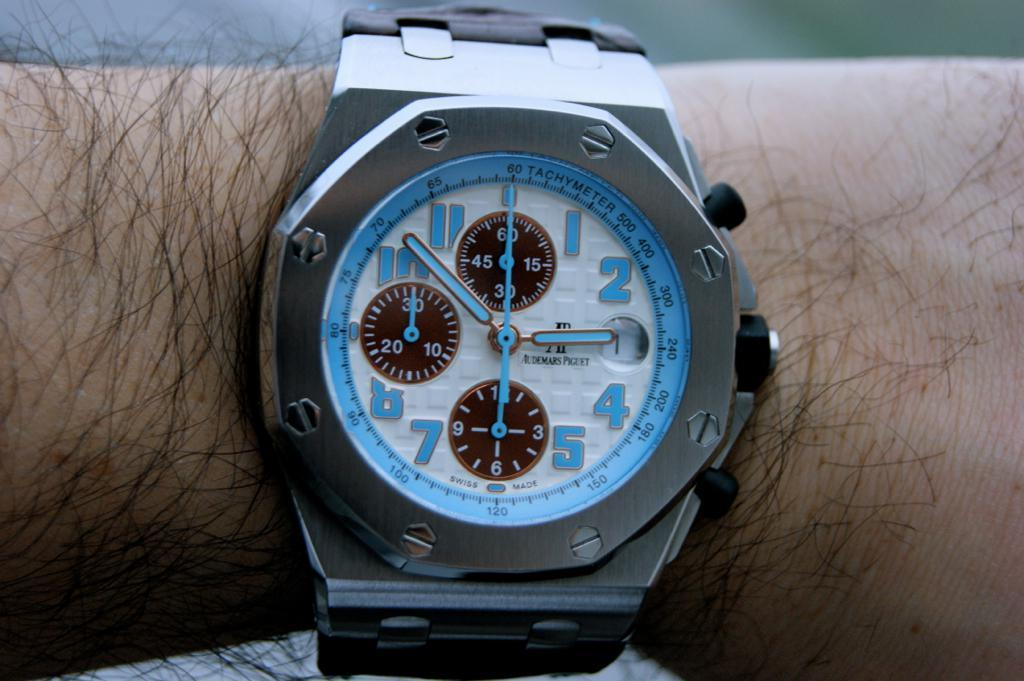<image>
Render a clear and concise summary of the photo. A watch on a hairy arm has a blue trim with a Tachymeter. 